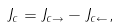<formula> <loc_0><loc_0><loc_500><loc_500>J _ { c } = J _ { c \rightarrow } - J _ { c \leftarrow } ,</formula> 